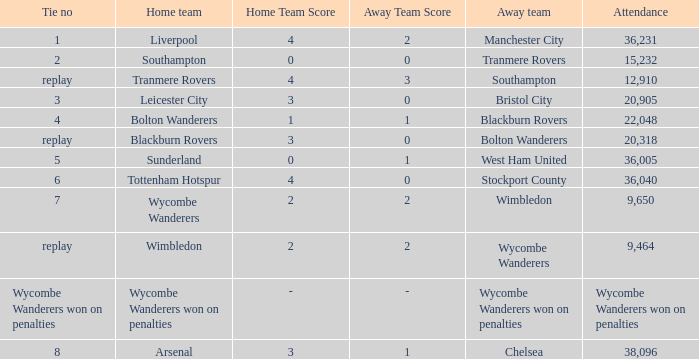What was the name of the away team that had a tie of 2? Tranmere Rovers. 